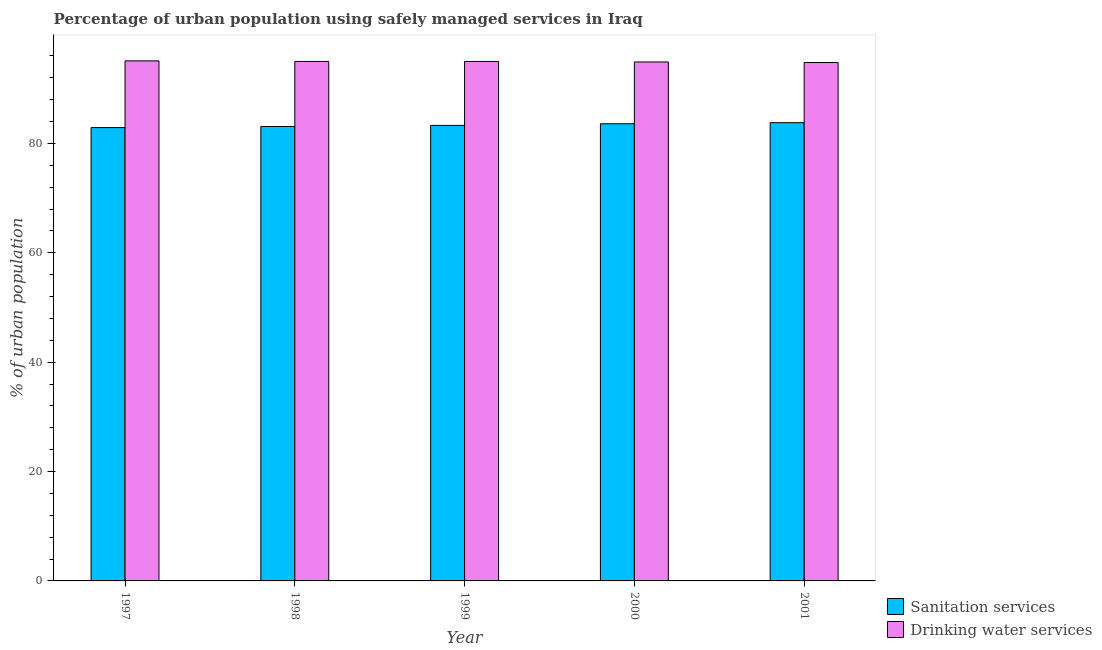Are the number of bars on each tick of the X-axis equal?
Provide a short and direct response. Yes. How many bars are there on the 1st tick from the left?
Provide a succinct answer. 2. In how many cases, is the number of bars for a given year not equal to the number of legend labels?
Ensure brevity in your answer.  0. What is the percentage of urban population who used sanitation services in 2001?
Offer a very short reply. 83.8. Across all years, what is the maximum percentage of urban population who used drinking water services?
Offer a terse response. 95.1. Across all years, what is the minimum percentage of urban population who used drinking water services?
Your response must be concise. 94.8. In which year was the percentage of urban population who used sanitation services minimum?
Your answer should be compact. 1997. What is the total percentage of urban population who used drinking water services in the graph?
Keep it short and to the point. 474.8. What is the difference between the percentage of urban population who used drinking water services in 1998 and that in 2000?
Give a very brief answer. 0.1. What is the difference between the percentage of urban population who used drinking water services in 2000 and the percentage of urban population who used sanitation services in 2001?
Give a very brief answer. 0.1. What is the average percentage of urban population who used sanitation services per year?
Make the answer very short. 83.34. In the year 1997, what is the difference between the percentage of urban population who used drinking water services and percentage of urban population who used sanitation services?
Provide a succinct answer. 0. What is the ratio of the percentage of urban population who used sanitation services in 1997 to that in 1998?
Your response must be concise. 1. Is the difference between the percentage of urban population who used drinking water services in 1997 and 1999 greater than the difference between the percentage of urban population who used sanitation services in 1997 and 1999?
Ensure brevity in your answer.  No. What is the difference between the highest and the second highest percentage of urban population who used drinking water services?
Your answer should be compact. 0.1. What is the difference between the highest and the lowest percentage of urban population who used sanitation services?
Your answer should be very brief. 0.9. What does the 2nd bar from the left in 1997 represents?
Offer a very short reply. Drinking water services. What does the 2nd bar from the right in 1998 represents?
Your response must be concise. Sanitation services. What is the difference between two consecutive major ticks on the Y-axis?
Provide a short and direct response. 20. Are the values on the major ticks of Y-axis written in scientific E-notation?
Make the answer very short. No. Does the graph contain grids?
Your answer should be compact. No. Where does the legend appear in the graph?
Keep it short and to the point. Bottom right. How many legend labels are there?
Offer a very short reply. 2. How are the legend labels stacked?
Give a very brief answer. Vertical. What is the title of the graph?
Make the answer very short. Percentage of urban population using safely managed services in Iraq. What is the label or title of the X-axis?
Keep it short and to the point. Year. What is the label or title of the Y-axis?
Your response must be concise. % of urban population. What is the % of urban population in Sanitation services in 1997?
Provide a short and direct response. 82.9. What is the % of urban population in Drinking water services in 1997?
Ensure brevity in your answer.  95.1. What is the % of urban population of Sanitation services in 1998?
Your response must be concise. 83.1. What is the % of urban population in Sanitation services in 1999?
Offer a very short reply. 83.3. What is the % of urban population in Sanitation services in 2000?
Your answer should be compact. 83.6. What is the % of urban population in Drinking water services in 2000?
Give a very brief answer. 94.9. What is the % of urban population of Sanitation services in 2001?
Offer a very short reply. 83.8. What is the % of urban population in Drinking water services in 2001?
Provide a succinct answer. 94.8. Across all years, what is the maximum % of urban population in Sanitation services?
Offer a terse response. 83.8. Across all years, what is the maximum % of urban population in Drinking water services?
Offer a terse response. 95.1. Across all years, what is the minimum % of urban population in Sanitation services?
Offer a terse response. 82.9. Across all years, what is the minimum % of urban population of Drinking water services?
Your response must be concise. 94.8. What is the total % of urban population in Sanitation services in the graph?
Your response must be concise. 416.7. What is the total % of urban population in Drinking water services in the graph?
Provide a short and direct response. 474.8. What is the difference between the % of urban population of Sanitation services in 1997 and that in 1998?
Give a very brief answer. -0.2. What is the difference between the % of urban population of Sanitation services in 1997 and that in 2000?
Make the answer very short. -0.7. What is the difference between the % of urban population in Sanitation services in 1997 and that in 2001?
Make the answer very short. -0.9. What is the difference between the % of urban population in Drinking water services in 1997 and that in 2001?
Keep it short and to the point. 0.3. What is the difference between the % of urban population of Sanitation services in 1998 and that in 2000?
Your answer should be compact. -0.5. What is the difference between the % of urban population of Drinking water services in 1999 and that in 2001?
Provide a short and direct response. 0.2. What is the difference between the % of urban population in Drinking water services in 2000 and that in 2001?
Ensure brevity in your answer.  0.1. What is the difference between the % of urban population of Sanitation services in 1997 and the % of urban population of Drinking water services in 1998?
Your answer should be compact. -12.1. What is the difference between the % of urban population in Sanitation services in 1997 and the % of urban population in Drinking water services in 1999?
Ensure brevity in your answer.  -12.1. What is the difference between the % of urban population of Sanitation services in 1997 and the % of urban population of Drinking water services in 2001?
Offer a terse response. -11.9. What is the difference between the % of urban population in Sanitation services in 1998 and the % of urban population in Drinking water services in 2001?
Ensure brevity in your answer.  -11.7. What is the difference between the % of urban population in Sanitation services in 1999 and the % of urban population in Drinking water services in 2000?
Your answer should be compact. -11.6. What is the difference between the % of urban population of Sanitation services in 2000 and the % of urban population of Drinking water services in 2001?
Your answer should be very brief. -11.2. What is the average % of urban population of Sanitation services per year?
Offer a very short reply. 83.34. What is the average % of urban population in Drinking water services per year?
Offer a terse response. 94.96. In the year 1997, what is the difference between the % of urban population of Sanitation services and % of urban population of Drinking water services?
Provide a succinct answer. -12.2. In the year 1998, what is the difference between the % of urban population in Sanitation services and % of urban population in Drinking water services?
Offer a very short reply. -11.9. What is the ratio of the % of urban population in Sanitation services in 1997 to that in 1998?
Keep it short and to the point. 1. What is the ratio of the % of urban population in Drinking water services in 1997 to that in 1998?
Offer a very short reply. 1. What is the ratio of the % of urban population in Sanitation services in 1997 to that in 1999?
Your answer should be compact. 1. What is the ratio of the % of urban population of Drinking water services in 1997 to that in 2000?
Offer a very short reply. 1. What is the ratio of the % of urban population of Sanitation services in 1997 to that in 2001?
Give a very brief answer. 0.99. What is the ratio of the % of urban population of Drinking water services in 1998 to that in 1999?
Your response must be concise. 1. What is the ratio of the % of urban population of Sanitation services in 1999 to that in 2000?
Ensure brevity in your answer.  1. What is the ratio of the % of urban population in Drinking water services in 2000 to that in 2001?
Make the answer very short. 1. What is the difference between the highest and the lowest % of urban population of Sanitation services?
Offer a terse response. 0.9. 